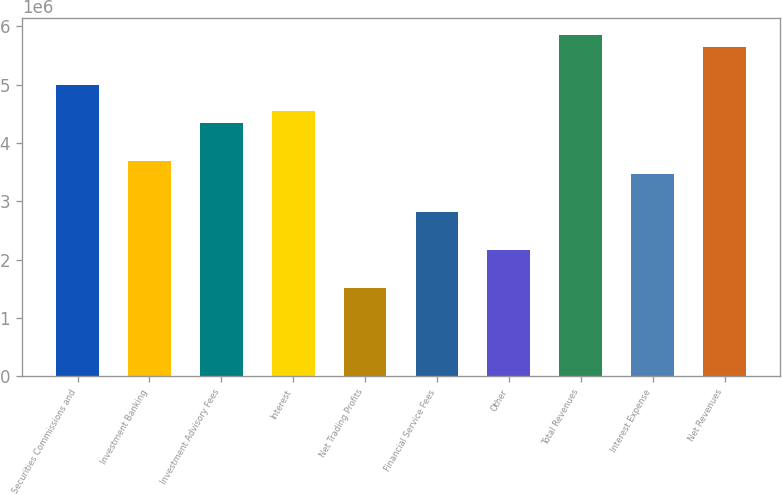Convert chart. <chart><loc_0><loc_0><loc_500><loc_500><bar_chart><fcel>Securities Commissions and<fcel>Investment Banking<fcel>Investment Advisory Fees<fcel>Interest<fcel>Net Trading Profits<fcel>Financial Service Fees<fcel>Other<fcel>Total Revenues<fcel>Interest Expense<fcel>Net Revenues<nl><fcel>4.98685e+06<fcel>3.68593e+06<fcel>4.33639e+06<fcel>4.55321e+06<fcel>1.51774e+06<fcel>2.81865e+06<fcel>2.1682e+06<fcel>5.85413e+06<fcel>3.46911e+06<fcel>5.63731e+06<nl></chart> 